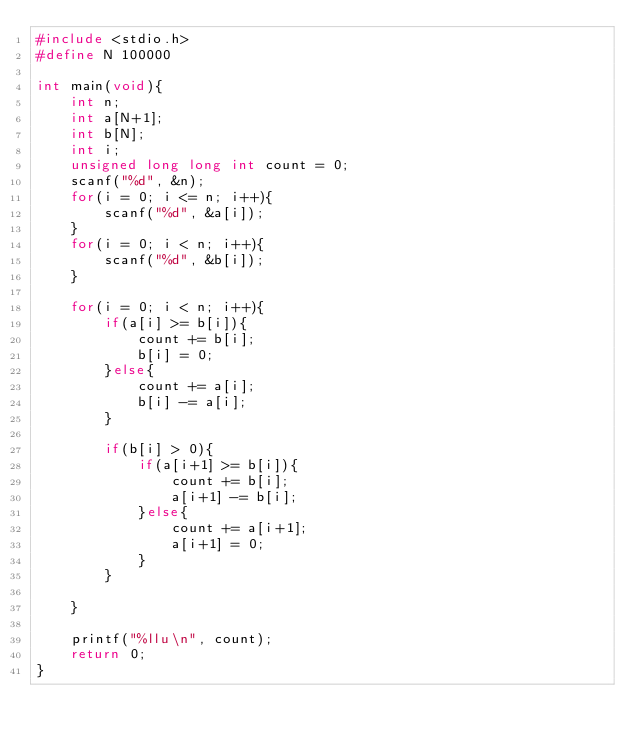<code> <loc_0><loc_0><loc_500><loc_500><_C_>#include <stdio.h>
#define N 100000

int main(void){
    int n;
    int a[N+1];
    int b[N];
    int i;
    unsigned long long int count = 0;
    scanf("%d", &n);
    for(i = 0; i <= n; i++){
        scanf("%d", &a[i]);
    }
    for(i = 0; i < n; i++){
        scanf("%d", &b[i]);
    }
    
    for(i = 0; i < n; i++){
        if(a[i] >= b[i]){
            count += b[i];
            b[i] = 0;
        }else{
            count += a[i];
            b[i] -= a[i];
        }
        
        if(b[i] > 0){
            if(a[i+1] >= b[i]){
                count += b[i];
                a[i+1] -= b[i];
            }else{
                count += a[i+1];
                a[i+1] = 0;
            }
        }
        
    }
    
    printf("%llu\n", count);
    return 0;
}</code> 